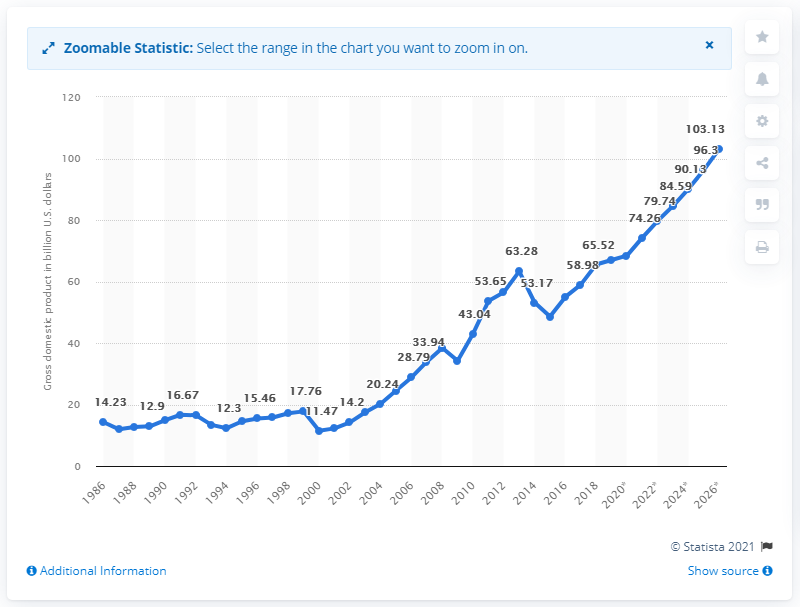Point out several critical features in this image. In 2019, Ghana's gross domestic product (GDP) was 67. 